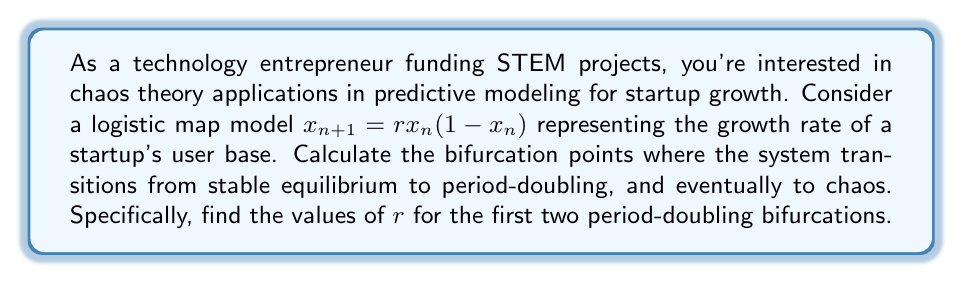Provide a solution to this math problem. To find the bifurcation points, we need to analyze the stability of the fixed points and their period-doubling behavior:

1. Find the fixed points:
   Set $x_{n+1} = x_n = x^*$
   $x^* = rx^*(1-x^*)$
   Solving this equation yields two fixed points:
   $x^*_1 = 0$ and $x^*_2 = 1 - \frac{1}{r}$

2. Analyze stability of $x^*_2$ (non-zero fixed point):
   The derivative of the map is $f'(x) = r(1-2x)$
   At $x^*_2$, $f'(x^*_2) = r(1-2(1-\frac{1}{r})) = 2-r$

3. The fixed point loses stability when $|f'(x^*_2)| = 1$:
   $|2-r| = 1$
   This occurs at $r = 3$ (the other solution, $r = 1$, is not relevant for positive growth)

4. For the period-doubling bifurcations, we need to find when the second iteration of the map becomes unstable:
   $f^2(x) = r^2x(1-x)(1-rx(1-x))$
   The derivative of this is complex, but evaluated at the fixed point and set to -1 (for period-doubling), it yields the equation:
   $r^2 - 2r - 3 = 0$

5. Solving this quadratic equation:
   $r = 1 \pm \sqrt{4} = 1 \pm 2$
   The positive solution is $r \approx 3.449489742783178$

6. The next period-doubling bifurcation occurs at approximately $r \approx 3.544090359551373$, which can be found numerically or through further analysis of higher-order iterations.
Answer: First bifurcation: $r = 3$
Second bifurcation: $r \approx 3.449490$ 